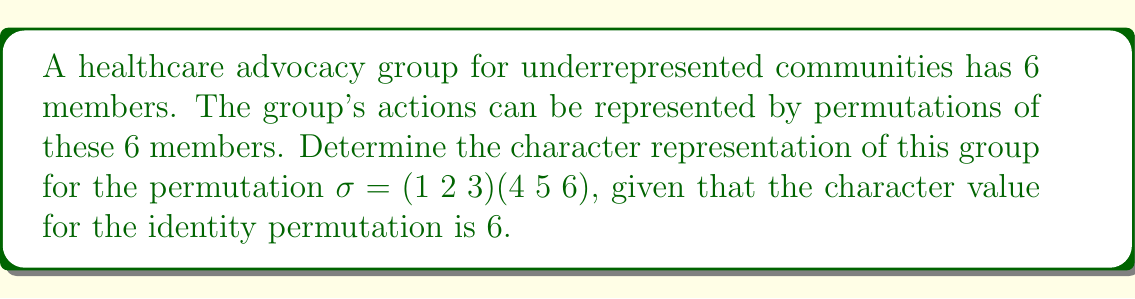Help me with this question. To determine the character representation for the given permutation, we'll follow these steps:

1) First, recall that the character of a permutation in the standard representation is given by:
   $$\chi(\sigma) = \text{number of fixed points} - 1$$

2) For the permutation $\sigma = (1 2 3)(4 5 6)$:
   - It consists of two 3-cycles
   - There are no fixed points (no element maps to itself)

3) Therefore, the number of fixed points is 0.

4) Applying the formula:
   $$\chi(\sigma) = 0 - 1 = -1$$

5) This means that for the permutation $\sigma$, the character value is -1.

6) We can verify this result by considering the trace of the permutation matrix:
   - The permutation matrix for $\sigma$ would have 0s on the main diagonal
   - The trace of this matrix (sum of diagonal elements) is 0
   - In the standard representation, the character is the trace minus 1
   - This confirms our result: $0 - 1 = -1$

7) Note: The fact that the character value for the identity permutation is 6 confirms that we are dealing with the standard representation of $S_6$ (the symmetric group on 6 elements), as expected for a group of 6 members.
Answer: $\chi(\sigma) = -1$ 